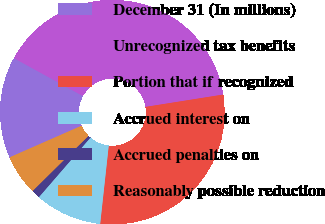<chart> <loc_0><loc_0><loc_500><loc_500><pie_chart><fcel>December 31 (In millions)<fcel>Unrecognized tax benefits<fcel>Portion that if recognized<fcel>Accrued interest on<fcel>Accrued penalties on<fcel>Reasonably possible reduction<nl><fcel>14.59%<fcel>39.49%<fcel>29.24%<fcel>9.62%<fcel>1.25%<fcel>5.8%<nl></chart> 